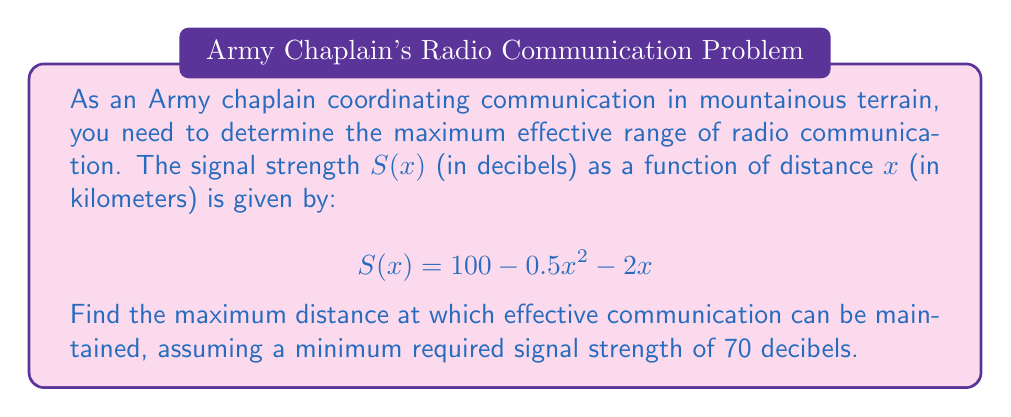Could you help me with this problem? To solve this problem, we'll follow these steps:

1) First, we need to find the distance at which the signal strength equals 70 decibels. This means solving the equation:

   $$70 = 100 - 0.5x^2 - 2x$$

2) Rearrange the equation:

   $$0.5x^2 + 2x - 30 = 0$$

3) This is a quadratic equation. We can solve it using the quadratic formula:

   $$x = \frac{-b \pm \sqrt{b^2 - 4ac}}{2a}$$

   where $a = 0.5$, $b = 2$, and $c = -30$

4) Substituting these values:

   $$x = \frac{-2 \pm \sqrt{2^2 - 4(0.5)(-30)}}{2(0.5)}$$

5) Simplify:

   $$x = \frac{-2 \pm \sqrt{4 + 60}}{1} = -2 \pm \sqrt{64} = -2 \pm 8$$

6) This gives us two solutions:

   $$x = -2 + 8 = 6$$ or $$x = -2 - 8 = -10$$

7) Since distance cannot be negative, we discard the negative solution.

Therefore, the maximum effective range for radio communication is 6 kilometers.
Answer: 6 km 